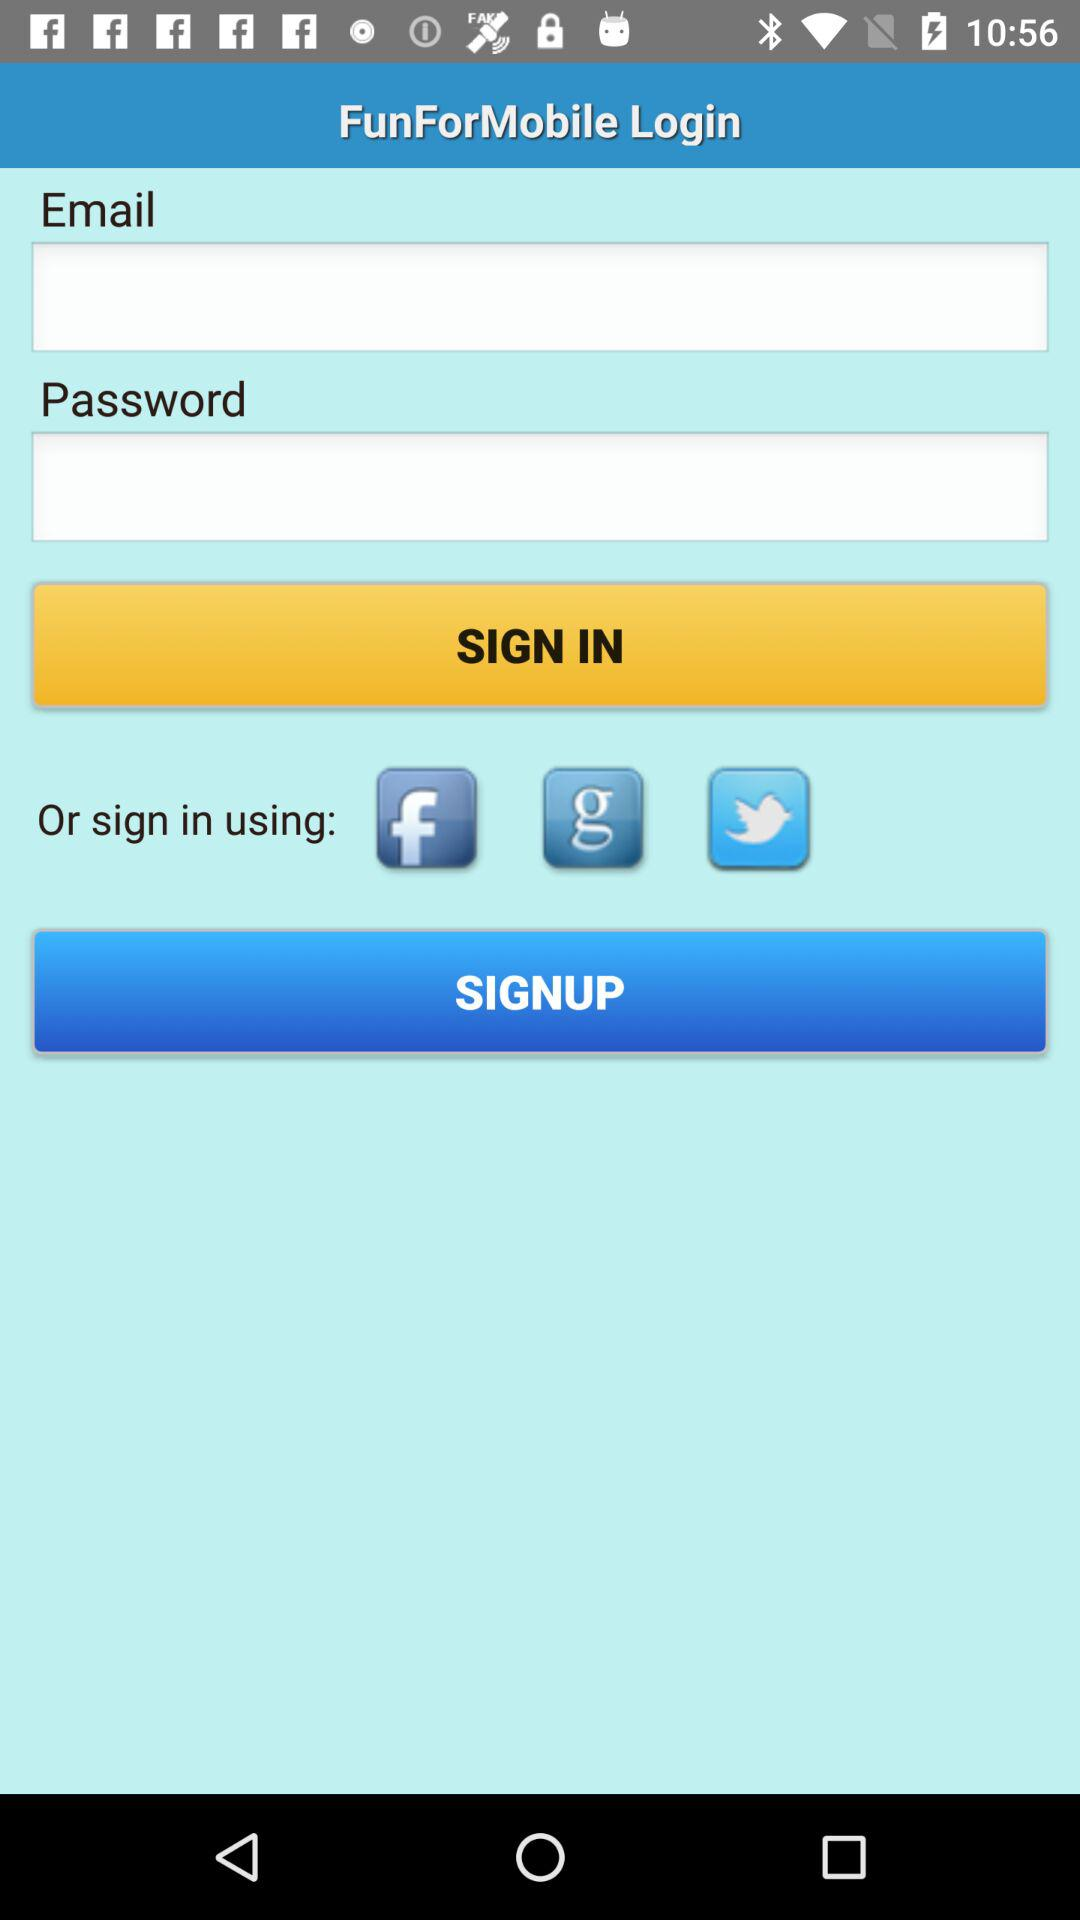Which are the different sign in options? The different sign in options are "Facebook", "Google" and "Twitter". 